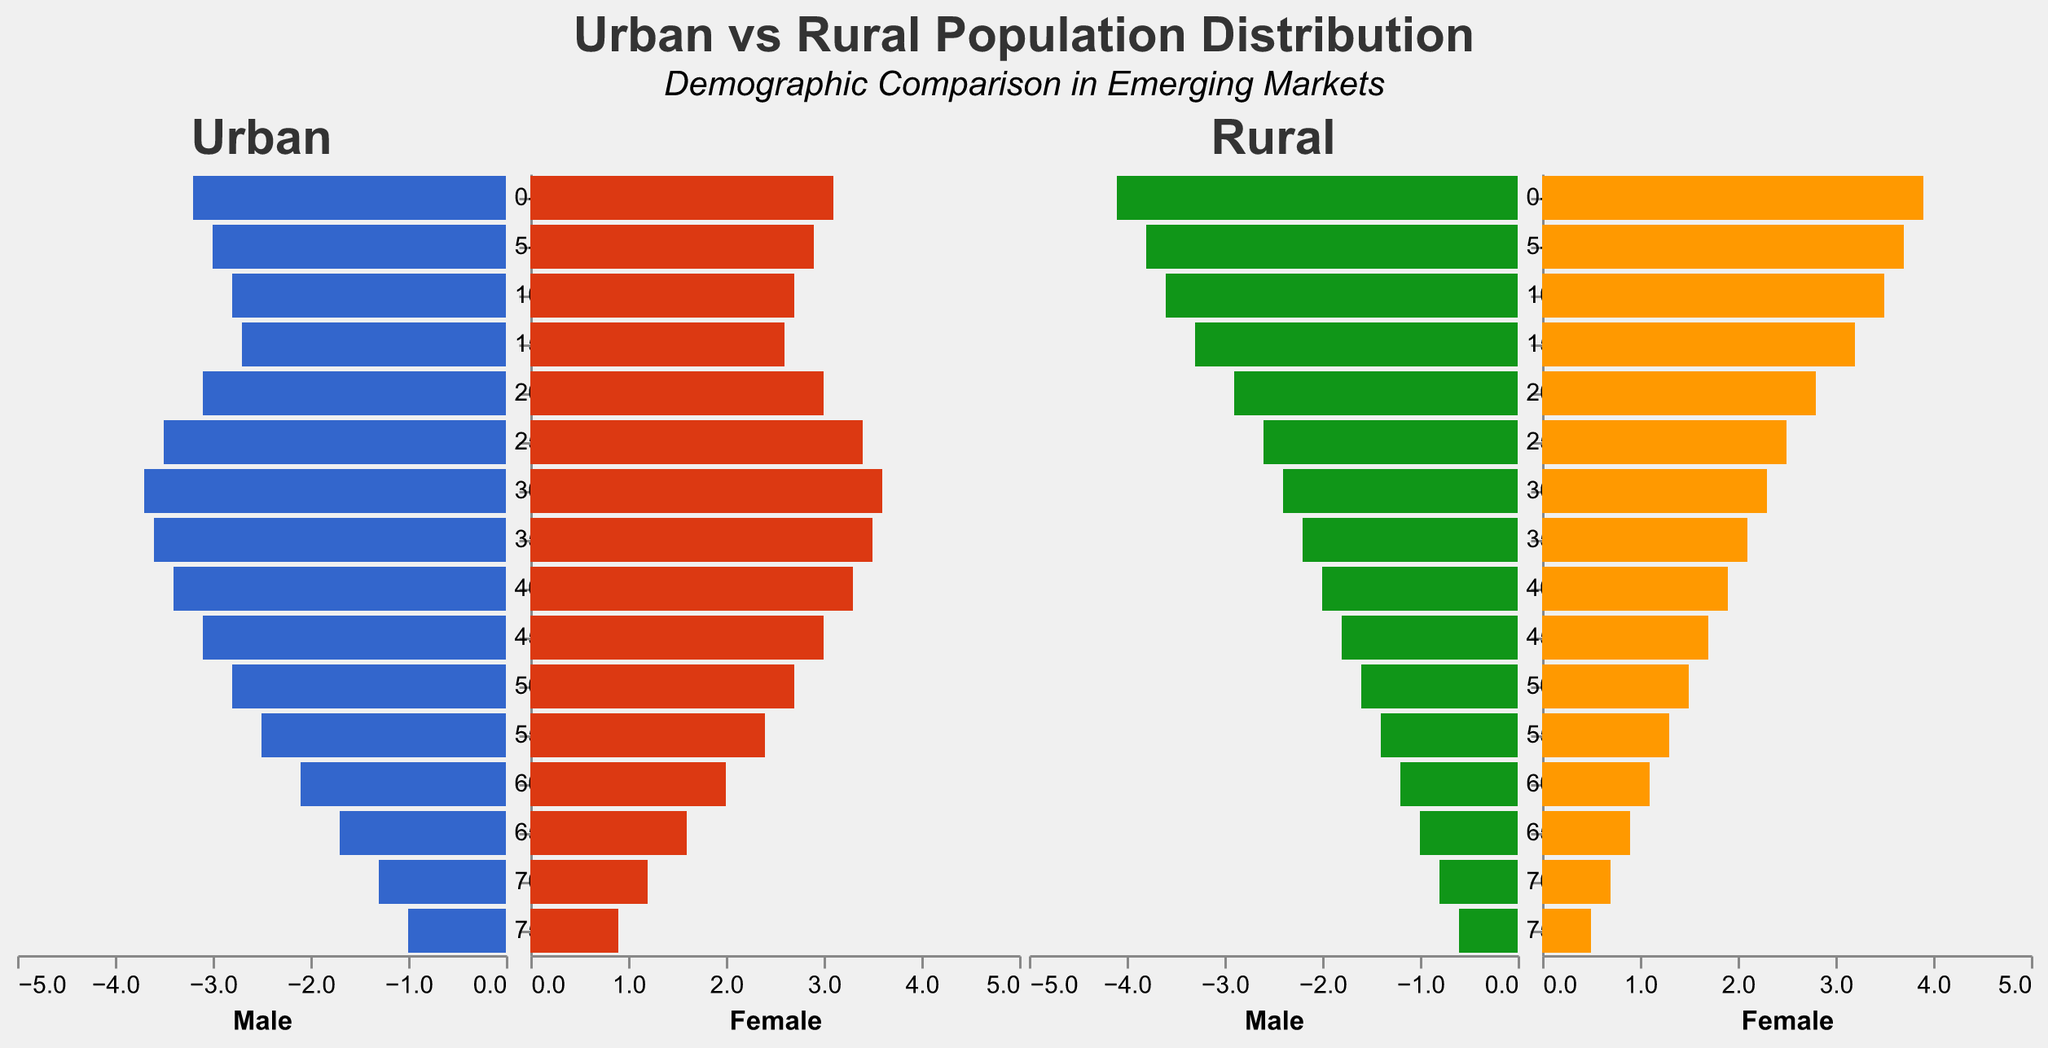What are the titles displayed at the top of the figure? The top part of the figure has two parts to the title, the main title and the subtitle. The main title is "Urban vs Rural Population Distribution," and the subtitle is "Demographic Comparison in Emerging Markets."
Answer: "Urban vs Rural Population Distribution" and "Demographic Comparison in Emerging Markets" What is the proportion of urban males in the age group 0-4? By looking at the bar height for urban males in the age group 0-4 at the negative scale, it is visually shown that the proportion is 3.2.
Answer: 3.2 Which has a higher percentage of population in the age group 30-34: urban or rural females? From the graph, we see that urban females in the age group 30-34 represent a higher percentage (3.6) as compared to rural females (2.3).
Answer: Urban females What is the percentage difference of rural females between the age groups 60-64 and 70-74? The percentage of rural females in the age group 60-64 is 1.1 and for 70-74 is 0.7. The difference is 1.1 - 0.7 = 0.4.
Answer: 0.4 Compare the percentage of urban males and females in the age group 25-29. By looking at the bar heights for urban males (3.5) and urban females (3.4) in the age group 25-29, we see that the percentage is slightly higher for males.
Answer: Urban males have a higher percentage Which age group has the least percentage of rural males? From the population pyramid, for rural males, the age group 75+ has the least percentage at 0.6.
Answer: 75+ What is the total percentage of rural females in the age groups from 0-14? Adding the percentages for rural females in age groups 0-4 (3.9), 5-9 (3.7), and 10-14 (3.5), the total is 3.9 + 3.7 + 3.5 = 11.1.
Answer: 11.1 In which age group do urban women outnumber urban men by the greatest margin? Upon examination, in the age group 30-34, urban females have a percentage of 3.6 while urban males have 3.7. The difference is minimal. The largest difference appears in the age group 25-29, where females are at 3.4 and males at 3.5, which is still minimal. Urban women do have a slight lead in the 0-4 age group (by 0.1).
Answer: 0-4 age group What is the combined percentage of urban males and females in the age group 15-19? By adding urban males (2.7) and urban females (2.6), the combined percentage is 2.7 + 2.6 = 5.3.
Answer: 5.3 